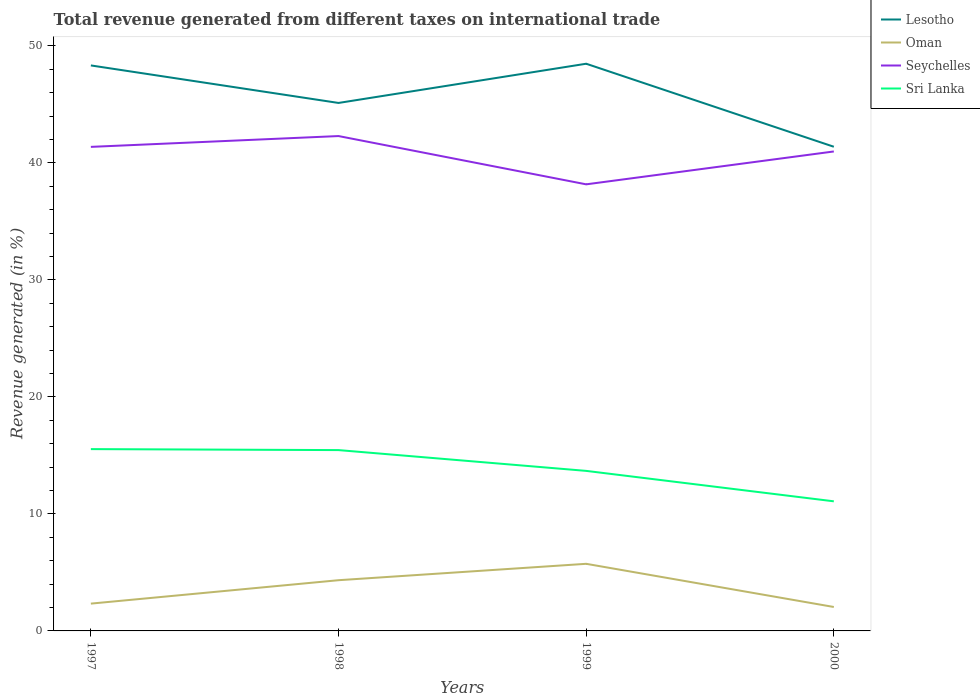How many different coloured lines are there?
Ensure brevity in your answer.  4. Is the number of lines equal to the number of legend labels?
Offer a very short reply. Yes. Across all years, what is the maximum total revenue generated in Sri Lanka?
Offer a terse response. 11.08. What is the total total revenue generated in Seychelles in the graph?
Offer a terse response. -2.81. What is the difference between the highest and the second highest total revenue generated in Seychelles?
Offer a very short reply. 4.13. What is the difference between the highest and the lowest total revenue generated in Lesotho?
Keep it short and to the point. 2. Does the graph contain any zero values?
Offer a very short reply. No. Where does the legend appear in the graph?
Keep it short and to the point. Top right. What is the title of the graph?
Offer a terse response. Total revenue generated from different taxes on international trade. Does "Bulgaria" appear as one of the legend labels in the graph?
Ensure brevity in your answer.  No. What is the label or title of the Y-axis?
Keep it short and to the point. Revenue generated (in %). What is the Revenue generated (in %) of Lesotho in 1997?
Your answer should be very brief. 48.33. What is the Revenue generated (in %) of Oman in 1997?
Your response must be concise. 2.33. What is the Revenue generated (in %) of Seychelles in 1997?
Your response must be concise. 41.37. What is the Revenue generated (in %) in Sri Lanka in 1997?
Give a very brief answer. 15.54. What is the Revenue generated (in %) in Lesotho in 1998?
Your answer should be compact. 45.12. What is the Revenue generated (in %) in Oman in 1998?
Ensure brevity in your answer.  4.33. What is the Revenue generated (in %) in Seychelles in 1998?
Your answer should be very brief. 42.29. What is the Revenue generated (in %) of Sri Lanka in 1998?
Provide a succinct answer. 15.46. What is the Revenue generated (in %) in Lesotho in 1999?
Your answer should be compact. 48.48. What is the Revenue generated (in %) of Oman in 1999?
Provide a short and direct response. 5.74. What is the Revenue generated (in %) of Seychelles in 1999?
Provide a short and direct response. 38.17. What is the Revenue generated (in %) of Sri Lanka in 1999?
Give a very brief answer. 13.68. What is the Revenue generated (in %) of Lesotho in 2000?
Provide a succinct answer. 41.38. What is the Revenue generated (in %) of Oman in 2000?
Your answer should be compact. 2.05. What is the Revenue generated (in %) of Seychelles in 2000?
Make the answer very short. 40.98. What is the Revenue generated (in %) of Sri Lanka in 2000?
Make the answer very short. 11.08. Across all years, what is the maximum Revenue generated (in %) in Lesotho?
Keep it short and to the point. 48.48. Across all years, what is the maximum Revenue generated (in %) of Oman?
Your response must be concise. 5.74. Across all years, what is the maximum Revenue generated (in %) in Seychelles?
Provide a short and direct response. 42.29. Across all years, what is the maximum Revenue generated (in %) in Sri Lanka?
Your answer should be compact. 15.54. Across all years, what is the minimum Revenue generated (in %) in Lesotho?
Offer a very short reply. 41.38. Across all years, what is the minimum Revenue generated (in %) of Oman?
Ensure brevity in your answer.  2.05. Across all years, what is the minimum Revenue generated (in %) in Seychelles?
Your answer should be very brief. 38.17. Across all years, what is the minimum Revenue generated (in %) of Sri Lanka?
Ensure brevity in your answer.  11.08. What is the total Revenue generated (in %) in Lesotho in the graph?
Give a very brief answer. 183.31. What is the total Revenue generated (in %) in Oman in the graph?
Provide a succinct answer. 14.45. What is the total Revenue generated (in %) in Seychelles in the graph?
Offer a very short reply. 162.81. What is the total Revenue generated (in %) of Sri Lanka in the graph?
Provide a succinct answer. 55.75. What is the difference between the Revenue generated (in %) of Lesotho in 1997 and that in 1998?
Provide a short and direct response. 3.21. What is the difference between the Revenue generated (in %) of Oman in 1997 and that in 1998?
Provide a short and direct response. -2. What is the difference between the Revenue generated (in %) in Seychelles in 1997 and that in 1998?
Offer a very short reply. -0.92. What is the difference between the Revenue generated (in %) of Sri Lanka in 1997 and that in 1998?
Your response must be concise. 0.08. What is the difference between the Revenue generated (in %) of Lesotho in 1997 and that in 1999?
Your answer should be very brief. -0.14. What is the difference between the Revenue generated (in %) in Oman in 1997 and that in 1999?
Your answer should be compact. -3.4. What is the difference between the Revenue generated (in %) of Seychelles in 1997 and that in 1999?
Offer a very short reply. 3.2. What is the difference between the Revenue generated (in %) in Sri Lanka in 1997 and that in 1999?
Provide a short and direct response. 1.86. What is the difference between the Revenue generated (in %) of Lesotho in 1997 and that in 2000?
Ensure brevity in your answer.  6.95. What is the difference between the Revenue generated (in %) of Oman in 1997 and that in 2000?
Provide a short and direct response. 0.29. What is the difference between the Revenue generated (in %) of Seychelles in 1997 and that in 2000?
Your response must be concise. 0.39. What is the difference between the Revenue generated (in %) in Sri Lanka in 1997 and that in 2000?
Provide a succinct answer. 4.46. What is the difference between the Revenue generated (in %) in Lesotho in 1998 and that in 1999?
Offer a terse response. -3.35. What is the difference between the Revenue generated (in %) of Oman in 1998 and that in 1999?
Your answer should be very brief. -1.4. What is the difference between the Revenue generated (in %) of Seychelles in 1998 and that in 1999?
Provide a succinct answer. 4.13. What is the difference between the Revenue generated (in %) of Sri Lanka in 1998 and that in 1999?
Your answer should be very brief. 1.78. What is the difference between the Revenue generated (in %) of Lesotho in 1998 and that in 2000?
Your answer should be compact. 3.74. What is the difference between the Revenue generated (in %) in Oman in 1998 and that in 2000?
Keep it short and to the point. 2.29. What is the difference between the Revenue generated (in %) of Seychelles in 1998 and that in 2000?
Your answer should be very brief. 1.32. What is the difference between the Revenue generated (in %) in Sri Lanka in 1998 and that in 2000?
Offer a terse response. 4.38. What is the difference between the Revenue generated (in %) in Lesotho in 1999 and that in 2000?
Ensure brevity in your answer.  7.09. What is the difference between the Revenue generated (in %) of Oman in 1999 and that in 2000?
Keep it short and to the point. 3.69. What is the difference between the Revenue generated (in %) of Seychelles in 1999 and that in 2000?
Your answer should be very brief. -2.81. What is the difference between the Revenue generated (in %) of Sri Lanka in 1999 and that in 2000?
Offer a terse response. 2.6. What is the difference between the Revenue generated (in %) of Lesotho in 1997 and the Revenue generated (in %) of Oman in 1998?
Your response must be concise. 44. What is the difference between the Revenue generated (in %) in Lesotho in 1997 and the Revenue generated (in %) in Seychelles in 1998?
Provide a short and direct response. 6.04. What is the difference between the Revenue generated (in %) in Lesotho in 1997 and the Revenue generated (in %) in Sri Lanka in 1998?
Provide a succinct answer. 32.88. What is the difference between the Revenue generated (in %) in Oman in 1997 and the Revenue generated (in %) in Seychelles in 1998?
Keep it short and to the point. -39.96. What is the difference between the Revenue generated (in %) in Oman in 1997 and the Revenue generated (in %) in Sri Lanka in 1998?
Offer a terse response. -13.12. What is the difference between the Revenue generated (in %) in Seychelles in 1997 and the Revenue generated (in %) in Sri Lanka in 1998?
Ensure brevity in your answer.  25.92. What is the difference between the Revenue generated (in %) of Lesotho in 1997 and the Revenue generated (in %) of Oman in 1999?
Your answer should be very brief. 42.6. What is the difference between the Revenue generated (in %) of Lesotho in 1997 and the Revenue generated (in %) of Seychelles in 1999?
Offer a terse response. 10.16. What is the difference between the Revenue generated (in %) of Lesotho in 1997 and the Revenue generated (in %) of Sri Lanka in 1999?
Ensure brevity in your answer.  34.65. What is the difference between the Revenue generated (in %) in Oman in 1997 and the Revenue generated (in %) in Seychelles in 1999?
Your answer should be compact. -35.84. What is the difference between the Revenue generated (in %) in Oman in 1997 and the Revenue generated (in %) in Sri Lanka in 1999?
Your answer should be compact. -11.35. What is the difference between the Revenue generated (in %) in Seychelles in 1997 and the Revenue generated (in %) in Sri Lanka in 1999?
Offer a very short reply. 27.69. What is the difference between the Revenue generated (in %) of Lesotho in 1997 and the Revenue generated (in %) of Oman in 2000?
Provide a succinct answer. 46.28. What is the difference between the Revenue generated (in %) in Lesotho in 1997 and the Revenue generated (in %) in Seychelles in 2000?
Offer a terse response. 7.35. What is the difference between the Revenue generated (in %) in Lesotho in 1997 and the Revenue generated (in %) in Sri Lanka in 2000?
Your response must be concise. 37.25. What is the difference between the Revenue generated (in %) in Oman in 1997 and the Revenue generated (in %) in Seychelles in 2000?
Provide a short and direct response. -38.65. What is the difference between the Revenue generated (in %) in Oman in 1997 and the Revenue generated (in %) in Sri Lanka in 2000?
Provide a succinct answer. -8.74. What is the difference between the Revenue generated (in %) of Seychelles in 1997 and the Revenue generated (in %) of Sri Lanka in 2000?
Provide a short and direct response. 30.29. What is the difference between the Revenue generated (in %) of Lesotho in 1998 and the Revenue generated (in %) of Oman in 1999?
Offer a very short reply. 39.39. What is the difference between the Revenue generated (in %) in Lesotho in 1998 and the Revenue generated (in %) in Seychelles in 1999?
Make the answer very short. 6.96. What is the difference between the Revenue generated (in %) of Lesotho in 1998 and the Revenue generated (in %) of Sri Lanka in 1999?
Your answer should be compact. 31.45. What is the difference between the Revenue generated (in %) in Oman in 1998 and the Revenue generated (in %) in Seychelles in 1999?
Make the answer very short. -33.83. What is the difference between the Revenue generated (in %) of Oman in 1998 and the Revenue generated (in %) of Sri Lanka in 1999?
Offer a very short reply. -9.34. What is the difference between the Revenue generated (in %) of Seychelles in 1998 and the Revenue generated (in %) of Sri Lanka in 1999?
Ensure brevity in your answer.  28.62. What is the difference between the Revenue generated (in %) of Lesotho in 1998 and the Revenue generated (in %) of Oman in 2000?
Provide a short and direct response. 43.08. What is the difference between the Revenue generated (in %) of Lesotho in 1998 and the Revenue generated (in %) of Seychelles in 2000?
Offer a very short reply. 4.15. What is the difference between the Revenue generated (in %) of Lesotho in 1998 and the Revenue generated (in %) of Sri Lanka in 2000?
Your response must be concise. 34.05. What is the difference between the Revenue generated (in %) in Oman in 1998 and the Revenue generated (in %) in Seychelles in 2000?
Offer a very short reply. -36.64. What is the difference between the Revenue generated (in %) in Oman in 1998 and the Revenue generated (in %) in Sri Lanka in 2000?
Offer a terse response. -6.74. What is the difference between the Revenue generated (in %) in Seychelles in 1998 and the Revenue generated (in %) in Sri Lanka in 2000?
Provide a short and direct response. 31.22. What is the difference between the Revenue generated (in %) of Lesotho in 1999 and the Revenue generated (in %) of Oman in 2000?
Give a very brief answer. 46.43. What is the difference between the Revenue generated (in %) of Lesotho in 1999 and the Revenue generated (in %) of Seychelles in 2000?
Give a very brief answer. 7.5. What is the difference between the Revenue generated (in %) of Lesotho in 1999 and the Revenue generated (in %) of Sri Lanka in 2000?
Your answer should be compact. 37.4. What is the difference between the Revenue generated (in %) of Oman in 1999 and the Revenue generated (in %) of Seychelles in 2000?
Offer a terse response. -35.24. What is the difference between the Revenue generated (in %) of Oman in 1999 and the Revenue generated (in %) of Sri Lanka in 2000?
Provide a short and direct response. -5.34. What is the difference between the Revenue generated (in %) of Seychelles in 1999 and the Revenue generated (in %) of Sri Lanka in 2000?
Offer a very short reply. 27.09. What is the average Revenue generated (in %) in Lesotho per year?
Keep it short and to the point. 45.83. What is the average Revenue generated (in %) of Oman per year?
Your answer should be compact. 3.61. What is the average Revenue generated (in %) of Seychelles per year?
Your answer should be very brief. 40.7. What is the average Revenue generated (in %) in Sri Lanka per year?
Your answer should be very brief. 13.94. In the year 1997, what is the difference between the Revenue generated (in %) in Lesotho and Revenue generated (in %) in Oman?
Provide a short and direct response. 46. In the year 1997, what is the difference between the Revenue generated (in %) of Lesotho and Revenue generated (in %) of Seychelles?
Ensure brevity in your answer.  6.96. In the year 1997, what is the difference between the Revenue generated (in %) in Lesotho and Revenue generated (in %) in Sri Lanka?
Provide a short and direct response. 32.79. In the year 1997, what is the difference between the Revenue generated (in %) of Oman and Revenue generated (in %) of Seychelles?
Give a very brief answer. -39.04. In the year 1997, what is the difference between the Revenue generated (in %) in Oman and Revenue generated (in %) in Sri Lanka?
Your response must be concise. -13.21. In the year 1997, what is the difference between the Revenue generated (in %) in Seychelles and Revenue generated (in %) in Sri Lanka?
Keep it short and to the point. 25.83. In the year 1998, what is the difference between the Revenue generated (in %) in Lesotho and Revenue generated (in %) in Oman?
Your answer should be compact. 40.79. In the year 1998, what is the difference between the Revenue generated (in %) of Lesotho and Revenue generated (in %) of Seychelles?
Make the answer very short. 2.83. In the year 1998, what is the difference between the Revenue generated (in %) of Lesotho and Revenue generated (in %) of Sri Lanka?
Provide a short and direct response. 29.67. In the year 1998, what is the difference between the Revenue generated (in %) in Oman and Revenue generated (in %) in Seychelles?
Your answer should be compact. -37.96. In the year 1998, what is the difference between the Revenue generated (in %) of Oman and Revenue generated (in %) of Sri Lanka?
Ensure brevity in your answer.  -11.12. In the year 1998, what is the difference between the Revenue generated (in %) in Seychelles and Revenue generated (in %) in Sri Lanka?
Offer a very short reply. 26.84. In the year 1999, what is the difference between the Revenue generated (in %) in Lesotho and Revenue generated (in %) in Oman?
Keep it short and to the point. 42.74. In the year 1999, what is the difference between the Revenue generated (in %) of Lesotho and Revenue generated (in %) of Seychelles?
Keep it short and to the point. 10.31. In the year 1999, what is the difference between the Revenue generated (in %) of Lesotho and Revenue generated (in %) of Sri Lanka?
Your answer should be very brief. 34.8. In the year 1999, what is the difference between the Revenue generated (in %) in Oman and Revenue generated (in %) in Seychelles?
Provide a short and direct response. -32.43. In the year 1999, what is the difference between the Revenue generated (in %) in Oman and Revenue generated (in %) in Sri Lanka?
Offer a terse response. -7.94. In the year 1999, what is the difference between the Revenue generated (in %) of Seychelles and Revenue generated (in %) of Sri Lanka?
Give a very brief answer. 24.49. In the year 2000, what is the difference between the Revenue generated (in %) in Lesotho and Revenue generated (in %) in Oman?
Provide a succinct answer. 39.33. In the year 2000, what is the difference between the Revenue generated (in %) of Lesotho and Revenue generated (in %) of Seychelles?
Keep it short and to the point. 0.4. In the year 2000, what is the difference between the Revenue generated (in %) in Lesotho and Revenue generated (in %) in Sri Lanka?
Make the answer very short. 30.3. In the year 2000, what is the difference between the Revenue generated (in %) of Oman and Revenue generated (in %) of Seychelles?
Give a very brief answer. -38.93. In the year 2000, what is the difference between the Revenue generated (in %) in Oman and Revenue generated (in %) in Sri Lanka?
Make the answer very short. -9.03. In the year 2000, what is the difference between the Revenue generated (in %) of Seychelles and Revenue generated (in %) of Sri Lanka?
Your response must be concise. 29.9. What is the ratio of the Revenue generated (in %) in Lesotho in 1997 to that in 1998?
Offer a very short reply. 1.07. What is the ratio of the Revenue generated (in %) in Oman in 1997 to that in 1998?
Make the answer very short. 0.54. What is the ratio of the Revenue generated (in %) in Seychelles in 1997 to that in 1998?
Offer a terse response. 0.98. What is the ratio of the Revenue generated (in %) of Sri Lanka in 1997 to that in 1998?
Provide a short and direct response. 1.01. What is the ratio of the Revenue generated (in %) of Lesotho in 1997 to that in 1999?
Keep it short and to the point. 1. What is the ratio of the Revenue generated (in %) in Oman in 1997 to that in 1999?
Offer a very short reply. 0.41. What is the ratio of the Revenue generated (in %) in Seychelles in 1997 to that in 1999?
Ensure brevity in your answer.  1.08. What is the ratio of the Revenue generated (in %) in Sri Lanka in 1997 to that in 1999?
Your response must be concise. 1.14. What is the ratio of the Revenue generated (in %) in Lesotho in 1997 to that in 2000?
Provide a short and direct response. 1.17. What is the ratio of the Revenue generated (in %) of Oman in 1997 to that in 2000?
Your answer should be very brief. 1.14. What is the ratio of the Revenue generated (in %) of Seychelles in 1997 to that in 2000?
Offer a terse response. 1.01. What is the ratio of the Revenue generated (in %) of Sri Lanka in 1997 to that in 2000?
Make the answer very short. 1.4. What is the ratio of the Revenue generated (in %) in Lesotho in 1998 to that in 1999?
Your response must be concise. 0.93. What is the ratio of the Revenue generated (in %) in Oman in 1998 to that in 1999?
Offer a very short reply. 0.76. What is the ratio of the Revenue generated (in %) of Seychelles in 1998 to that in 1999?
Ensure brevity in your answer.  1.11. What is the ratio of the Revenue generated (in %) of Sri Lanka in 1998 to that in 1999?
Provide a succinct answer. 1.13. What is the ratio of the Revenue generated (in %) in Lesotho in 1998 to that in 2000?
Your response must be concise. 1.09. What is the ratio of the Revenue generated (in %) of Oman in 1998 to that in 2000?
Give a very brief answer. 2.12. What is the ratio of the Revenue generated (in %) in Seychelles in 1998 to that in 2000?
Your answer should be very brief. 1.03. What is the ratio of the Revenue generated (in %) in Sri Lanka in 1998 to that in 2000?
Make the answer very short. 1.4. What is the ratio of the Revenue generated (in %) of Lesotho in 1999 to that in 2000?
Your response must be concise. 1.17. What is the ratio of the Revenue generated (in %) of Oman in 1999 to that in 2000?
Make the answer very short. 2.8. What is the ratio of the Revenue generated (in %) in Seychelles in 1999 to that in 2000?
Provide a succinct answer. 0.93. What is the ratio of the Revenue generated (in %) of Sri Lanka in 1999 to that in 2000?
Offer a terse response. 1.23. What is the difference between the highest and the second highest Revenue generated (in %) in Lesotho?
Your answer should be compact. 0.14. What is the difference between the highest and the second highest Revenue generated (in %) of Oman?
Offer a very short reply. 1.4. What is the difference between the highest and the second highest Revenue generated (in %) in Seychelles?
Provide a short and direct response. 0.92. What is the difference between the highest and the second highest Revenue generated (in %) in Sri Lanka?
Your answer should be compact. 0.08. What is the difference between the highest and the lowest Revenue generated (in %) in Lesotho?
Your answer should be very brief. 7.09. What is the difference between the highest and the lowest Revenue generated (in %) of Oman?
Keep it short and to the point. 3.69. What is the difference between the highest and the lowest Revenue generated (in %) of Seychelles?
Your answer should be very brief. 4.13. What is the difference between the highest and the lowest Revenue generated (in %) in Sri Lanka?
Provide a short and direct response. 4.46. 